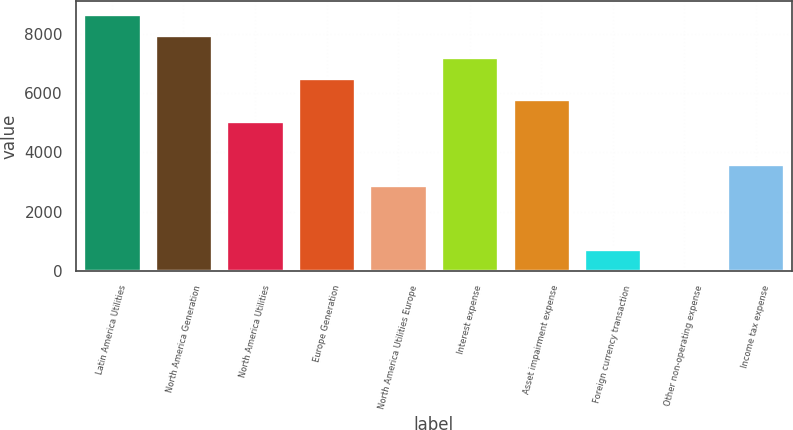Convert chart. <chart><loc_0><loc_0><loc_500><loc_500><bar_chart><fcel>Latin America Utilities<fcel>North America Generation<fcel>North America Utilities<fcel>Europe Generation<fcel>North America Utilities Europe<fcel>Interest expense<fcel>Asset impairment expense<fcel>Foreign currency transaction<fcel>Other non-operating expense<fcel>Income tax expense<nl><fcel>8665<fcel>7943.5<fcel>5057.5<fcel>6500.5<fcel>2893<fcel>7222<fcel>5779<fcel>728.5<fcel>7<fcel>3614.5<nl></chart> 